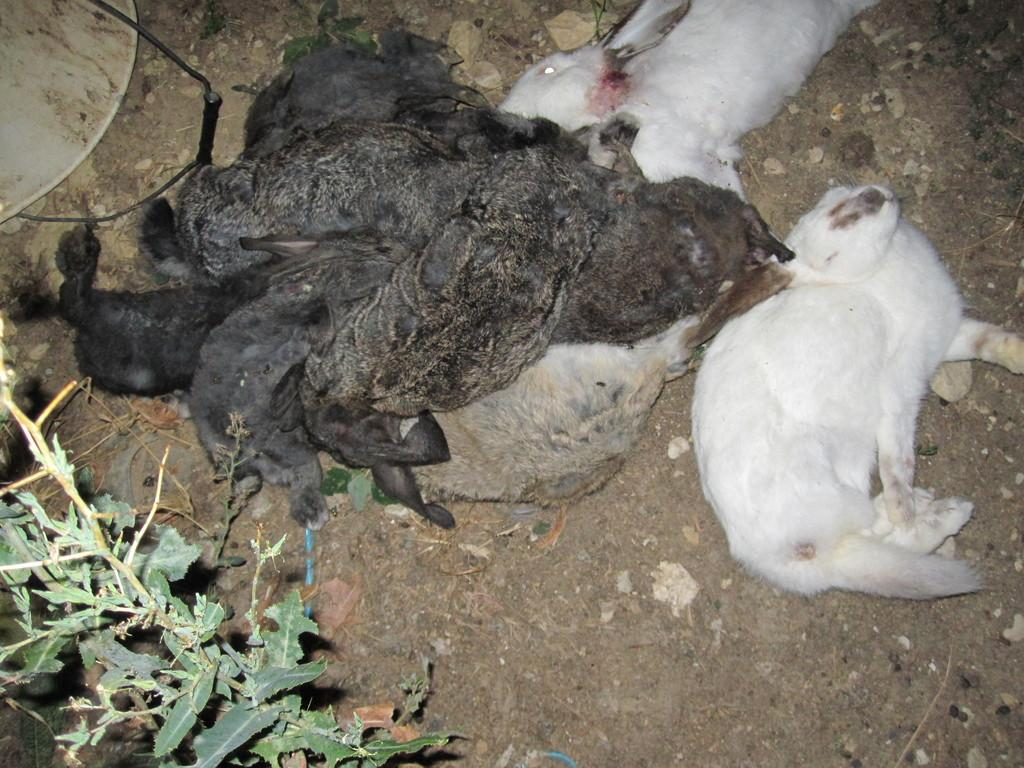What type of animals can be seen in the image? There are dead animals in the image. Where are the dead animals located? The dead animals are on the land. What else is present in the image besides the dead animals? There is a plant in front of the dead animals. How many frogs can be seen giving their approval in the image? There are no frogs present in the image, and no approval is being given by any animals or individuals. 